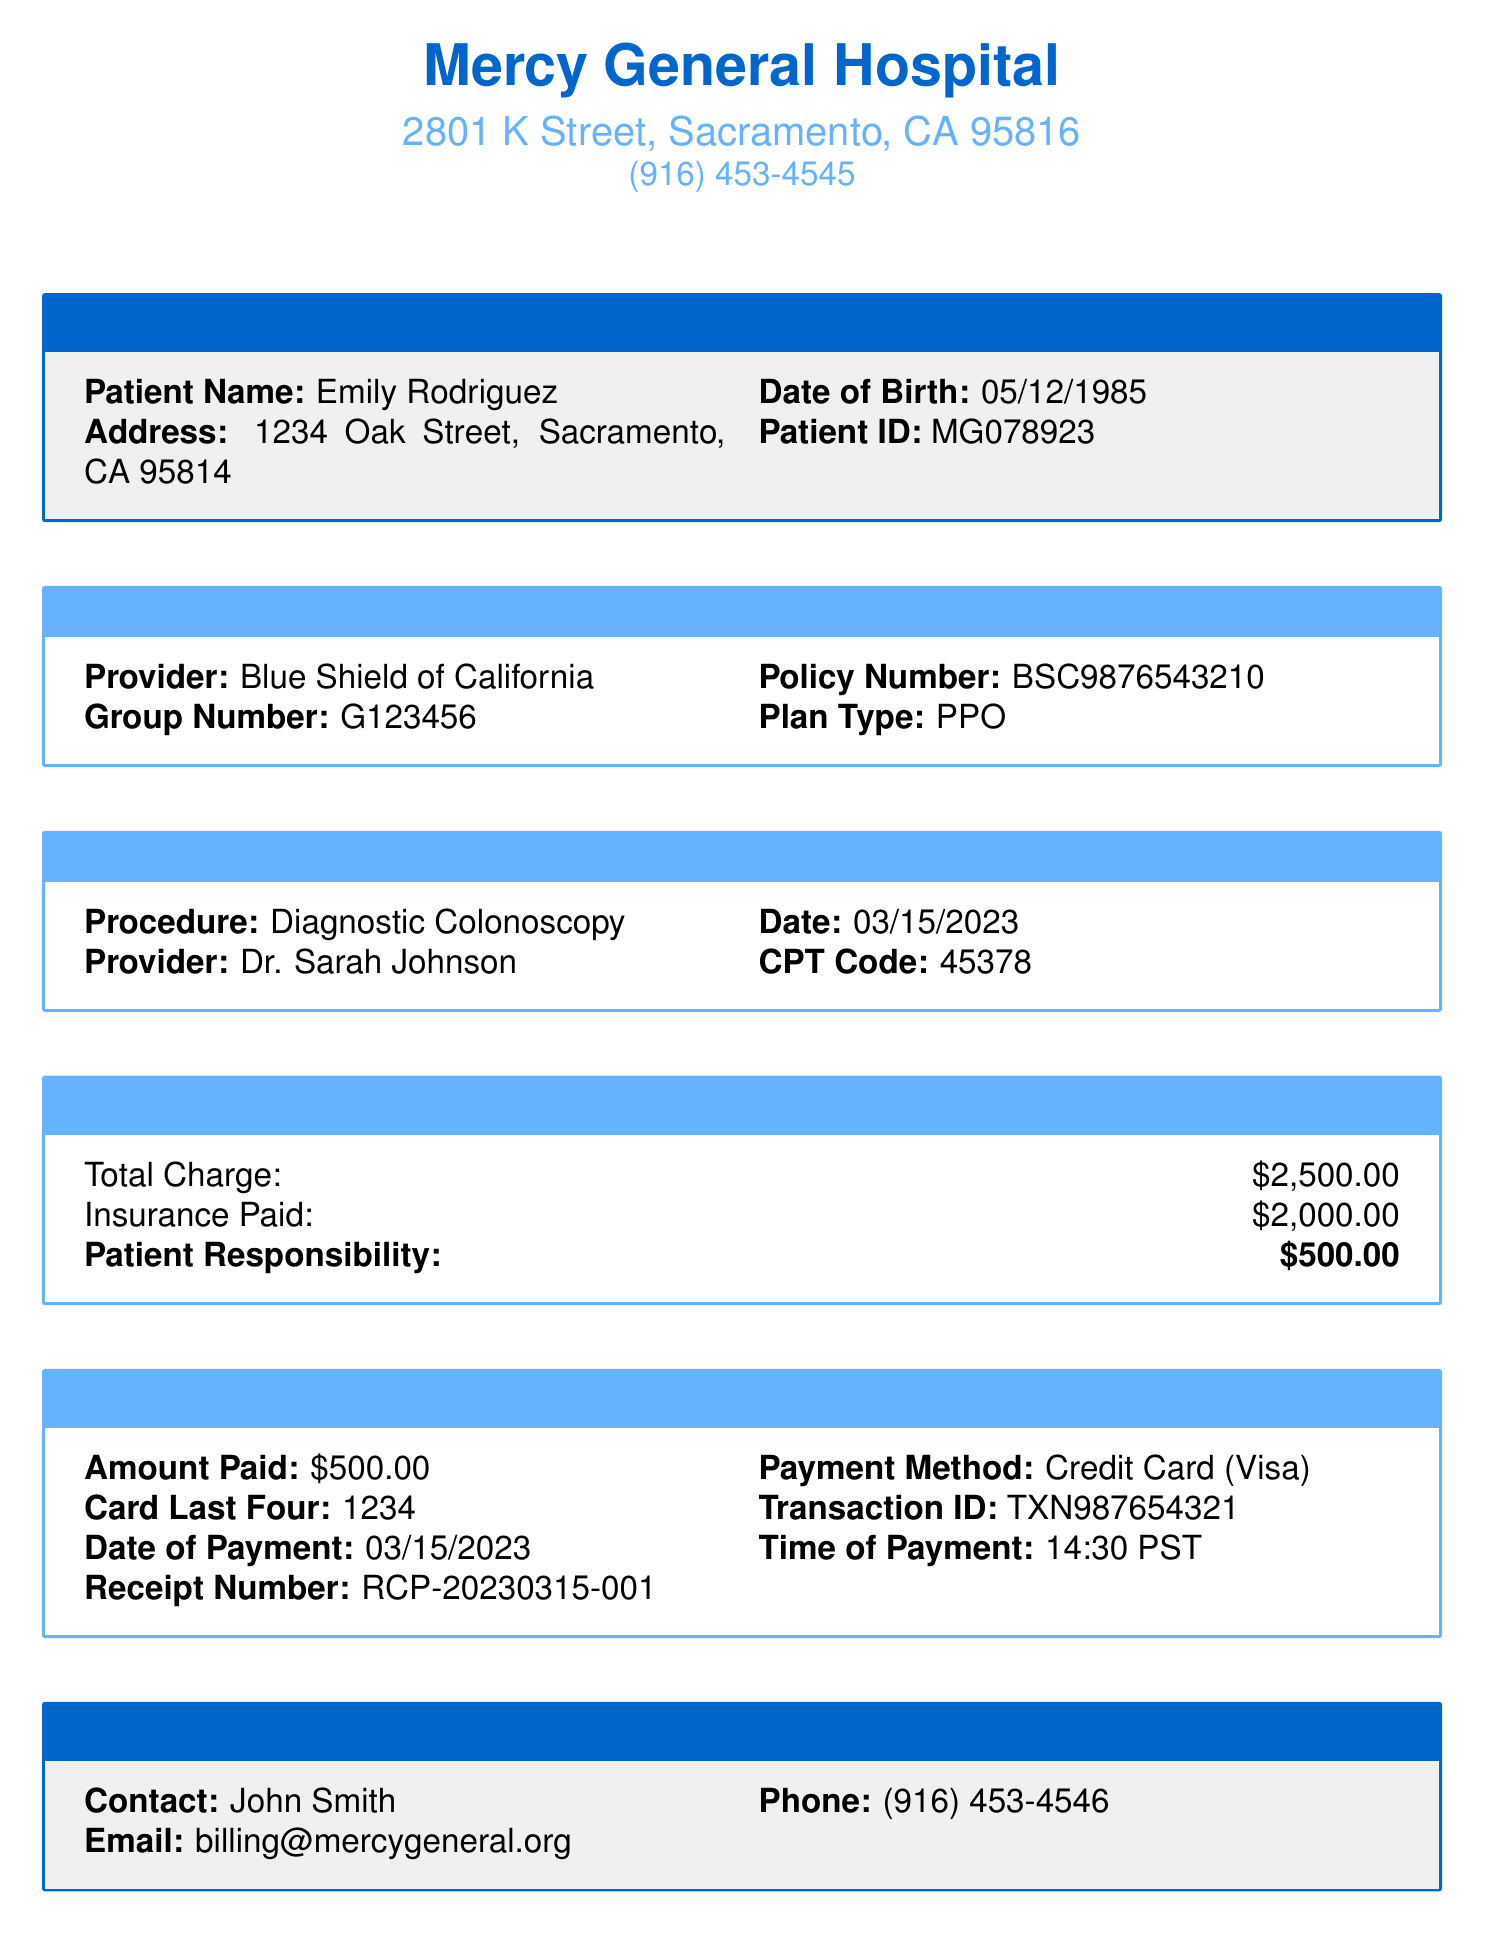What is the name of the healthcare facility? The document identifies the healthcare facility as Mercy General Hospital.
Answer: Mercy General Hospital What is the patient ID? The patient ID for Emily Rodriguez is provided in the document as MG078923.
Answer: MG078923 Who is the provider of the insurance? The insurance provider mentioned in the document is Blue Shield of California.
Answer: Blue Shield of California What is the total charge for the procedure? The total charge for the Diagnostic Colonoscopy is explicitly stated as $2500.00.
Answer: $2500.00 How much did the insurance pay? The document states that the insurance paid $2000.00 towards the procedure.
Answer: $2000.00 What is the amount the patient is responsible for? The patient responsibility is indicated in the document as $500.00.
Answer: $500.00 What method was used for payment? The payment method specified in the document is Credit Card.
Answer: Credit Card What type of card was used for the payment? The document specifies that the card type used for payment was Visa.
Answer: Visa Who can be contacted for billing inquiries? The contact person for billing inquiries listed in the document is John Smith.
Answer: John Smith 